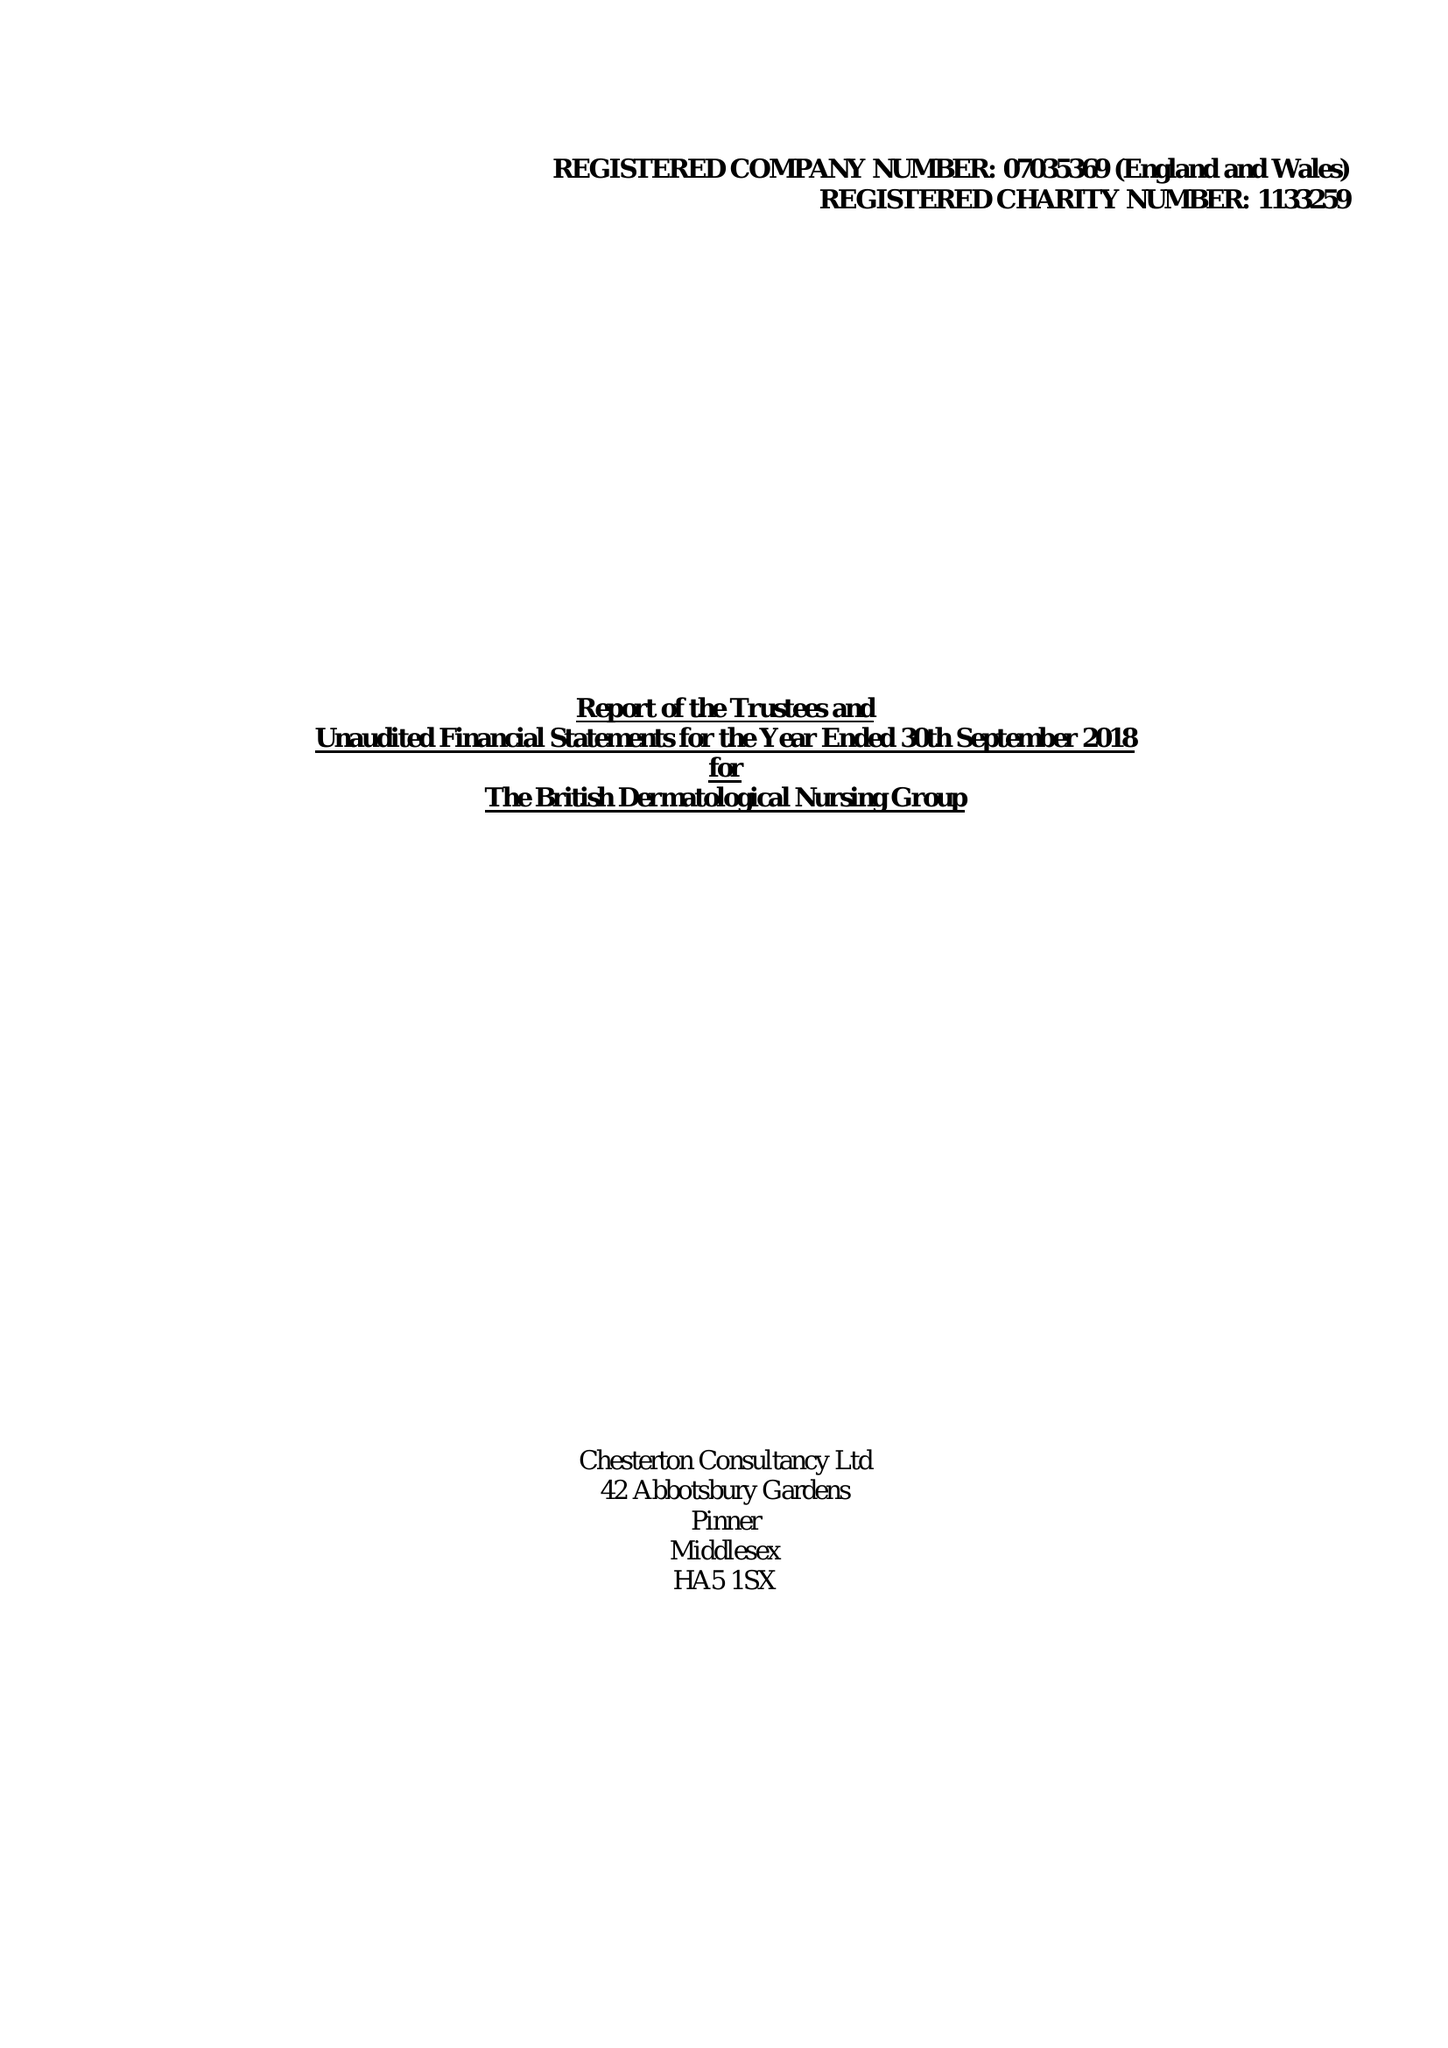What is the value for the charity_number?
Answer the question using a single word or phrase. 1133259 